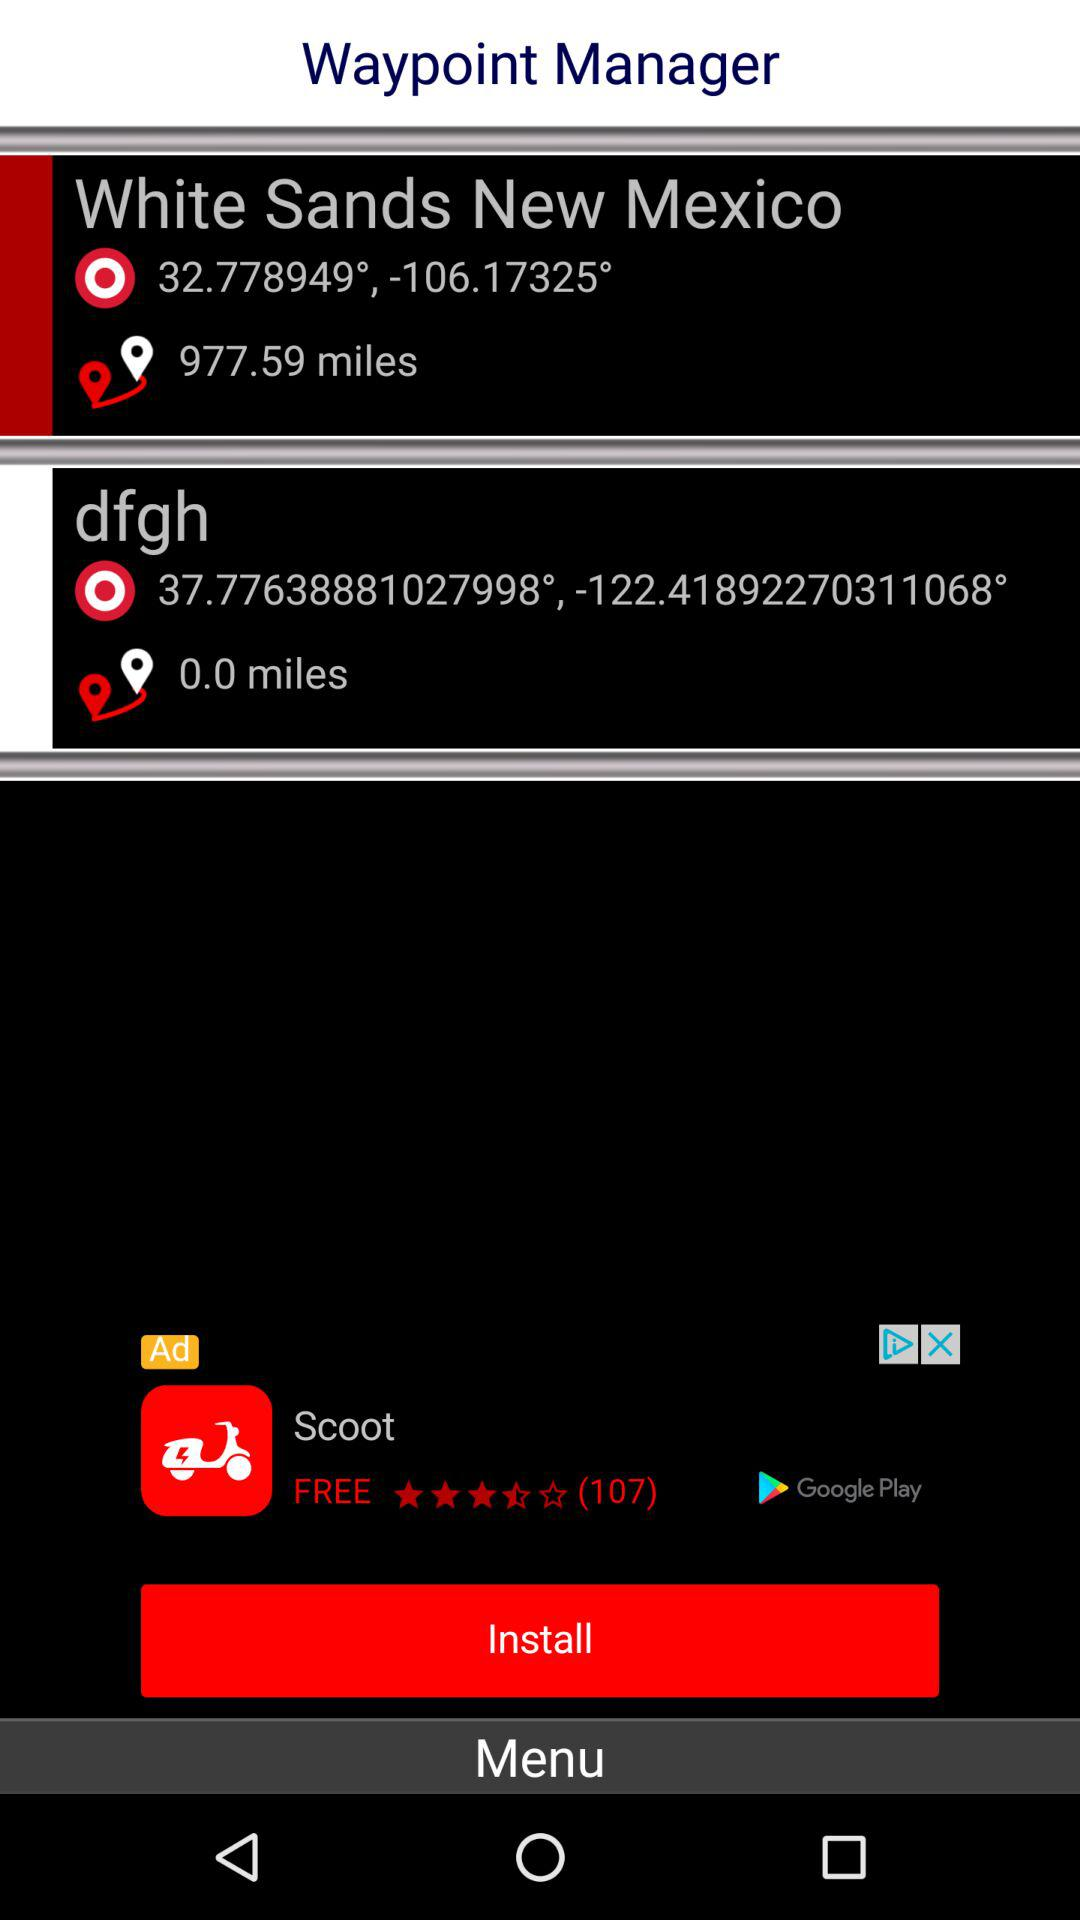How many miles more is the distance to White Sands New Mexico than the distance to dfgh?
Answer the question using a single word or phrase. 977.59 